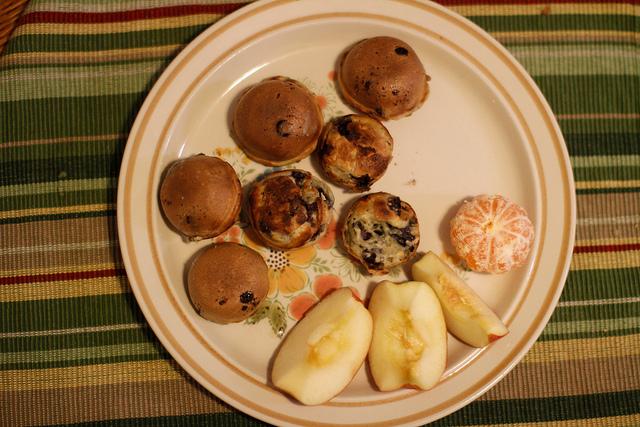What type of food is this?
Write a very short answer. Fruit and muffins. How many food types are here?
Write a very short answer. 3. What shape is the plate?
Keep it brief. Round. What is embroidered onto the table cloth?
Keep it brief. Stripes. How many teeth are on the plate?
Be succinct. 0. What is the print on the tablecloth?
Concise answer only. Striped. Is this pizza?
Short answer required. No. What design is the tablecloth?
Keep it brief. Stripes. 